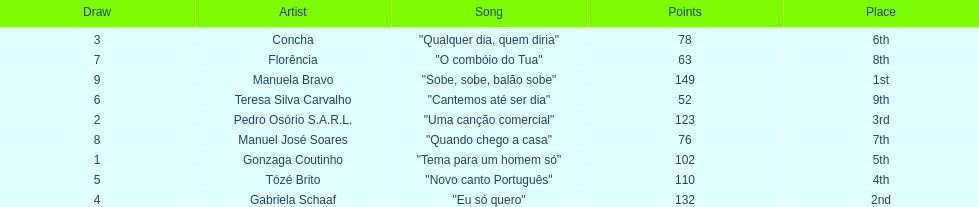Who scored the most points? Manuela Bravo. 